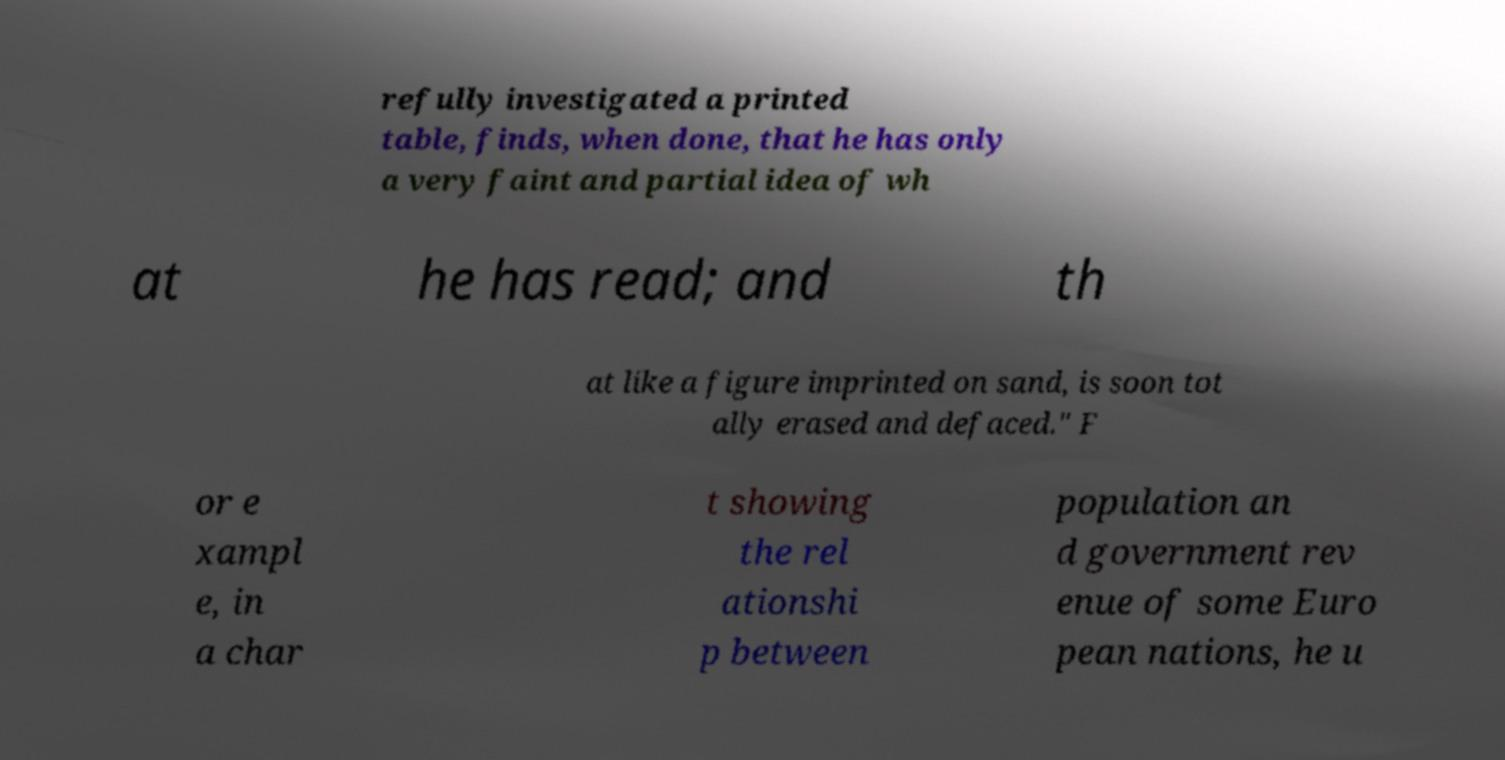Could you assist in decoding the text presented in this image and type it out clearly? refully investigated a printed table, finds, when done, that he has only a very faint and partial idea of wh at he has read; and th at like a figure imprinted on sand, is soon tot ally erased and defaced." F or e xampl e, in a char t showing the rel ationshi p between population an d government rev enue of some Euro pean nations, he u 